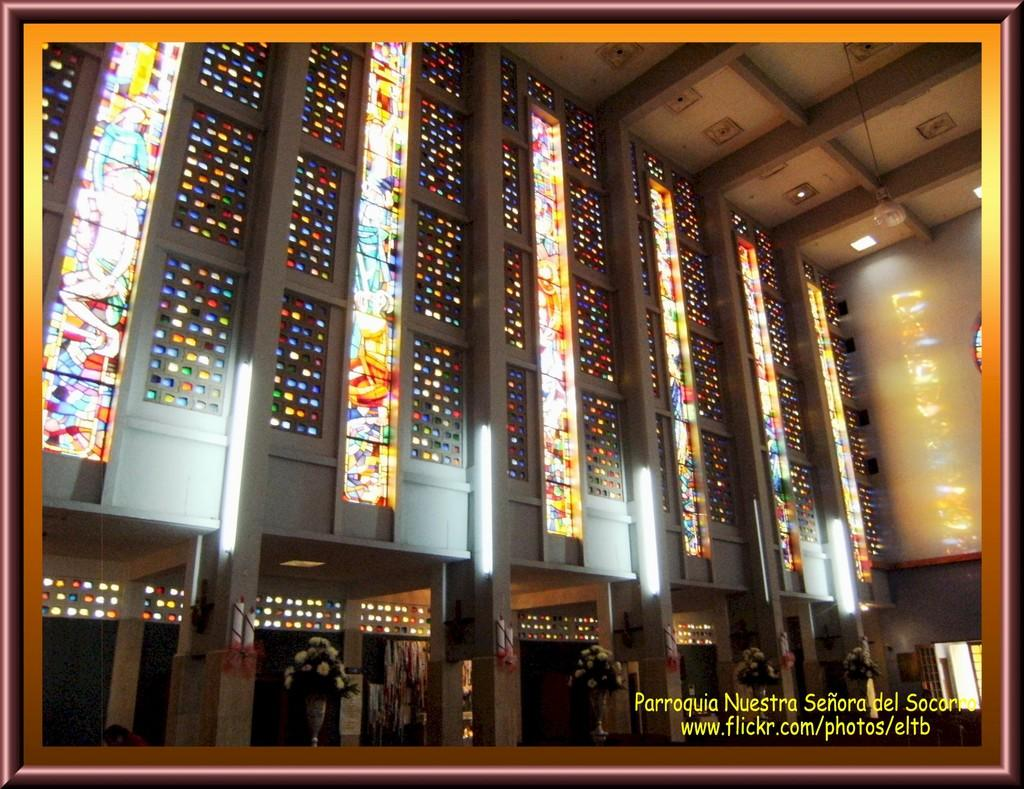What type of view is shown in the image? The image is an inside view of a building. What can be seen on a surface in the image? There are flower vases on a surface in the image. What can be used for illumination in the image? There are lights visible in the image. What architectural feature is present in the building? There are windows and pillars in the building. What is visible at the top of the image? The sky is visible at the top of the image. How many rings are visible on the branch in the image? There is no branch or rings present in the image. What type of system is being used to control the lights in the image? The image does not provide information about the lighting system being used. 